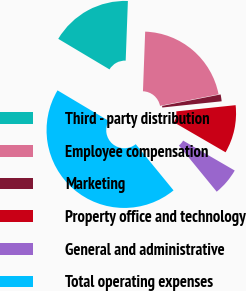Convert chart. <chart><loc_0><loc_0><loc_500><loc_500><pie_chart><fcel>Third - party distribution<fcel>Employee compensation<fcel>Marketing<fcel>Property office and technology<fcel>General and administrative<fcel>Total operating expenses<nl><fcel>17.03%<fcel>21.33%<fcel>1.42%<fcel>10.03%<fcel>5.72%<fcel>44.48%<nl></chart> 